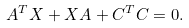Convert formula to latex. <formula><loc_0><loc_0><loc_500><loc_500>A ^ { T } X + X A + C ^ { T } C = 0 .</formula> 